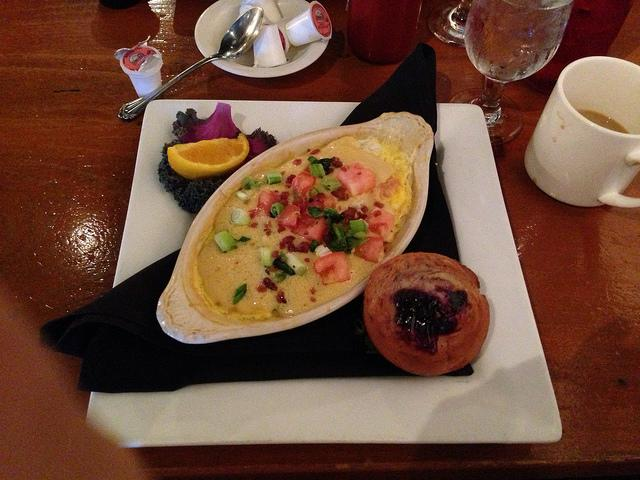What is in the little white plastic containers? Please explain your reasoning. coffee creamer. You can tell by the shape and size, as to what it holds. 